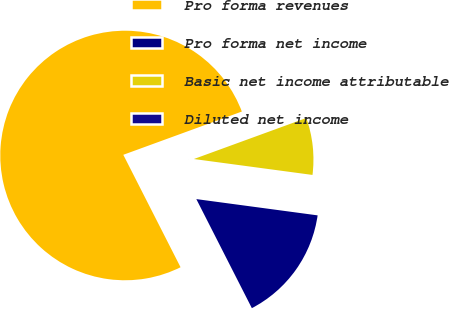Convert chart to OTSL. <chart><loc_0><loc_0><loc_500><loc_500><pie_chart><fcel>Pro forma revenues<fcel>Pro forma net income<fcel>Basic net income attributable<fcel>Diluted net income<nl><fcel>76.92%<fcel>15.38%<fcel>7.69%<fcel>0.0%<nl></chart> 